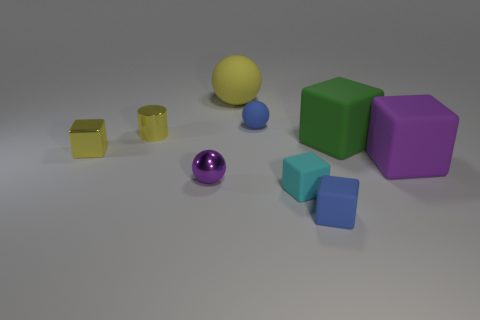How many objects in the image have edges, and can you describe their shapes? There are five objects with edges in the image. Two are cubes, with six equal square faces; two are rectangular prisms, one of which is a tall goldenrod color and the other is a shorter light blue; and finally, there's one purple cuboid with longer faces. 